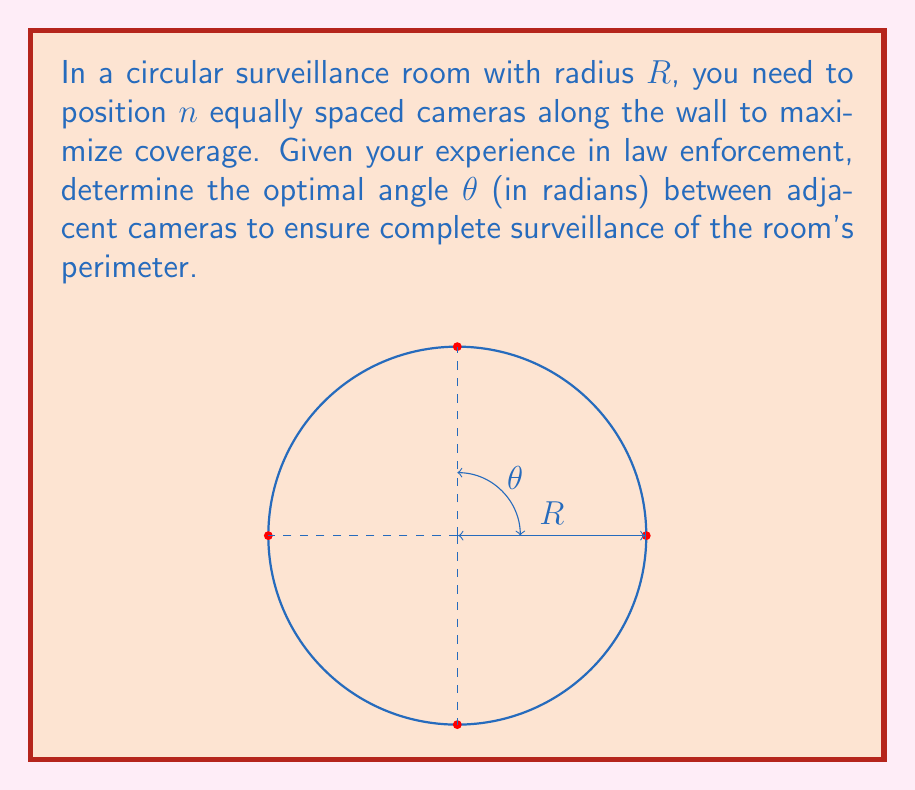Could you help me with this problem? To solve this problem, we'll follow these steps:

1) In a circular room, the cameras should be placed at equal intervals to ensure uniform coverage. The total angle around the center of the circle is $2\pi$ radians.

2) If we have $n$ cameras, the angle between each camera should be equal and sum up to $2\pi$. Let's call this angle $\theta$.

3) We can express this relationship mathematically as:

   $n \cdot \theta = 2\pi$

4) Solving for $\theta$:

   $\theta = \frac{2\pi}{n}$

5) This formula gives us the optimal angle between adjacent cameras in radians.

6) It's worth noting that this solution ensures that the cameras are positioned to cover the entire perimeter of the room. However, for complete coverage of the room's interior, additional considerations such as the cameras' field of view would need to be taken into account.

7) From a law enforcement perspective, this arrangement provides equal coverage to all parts of the room's perimeter, ensuring no blind spots where illegal activities could occur undetected.
Answer: $\theta = \frac{2\pi}{n}$ radians 